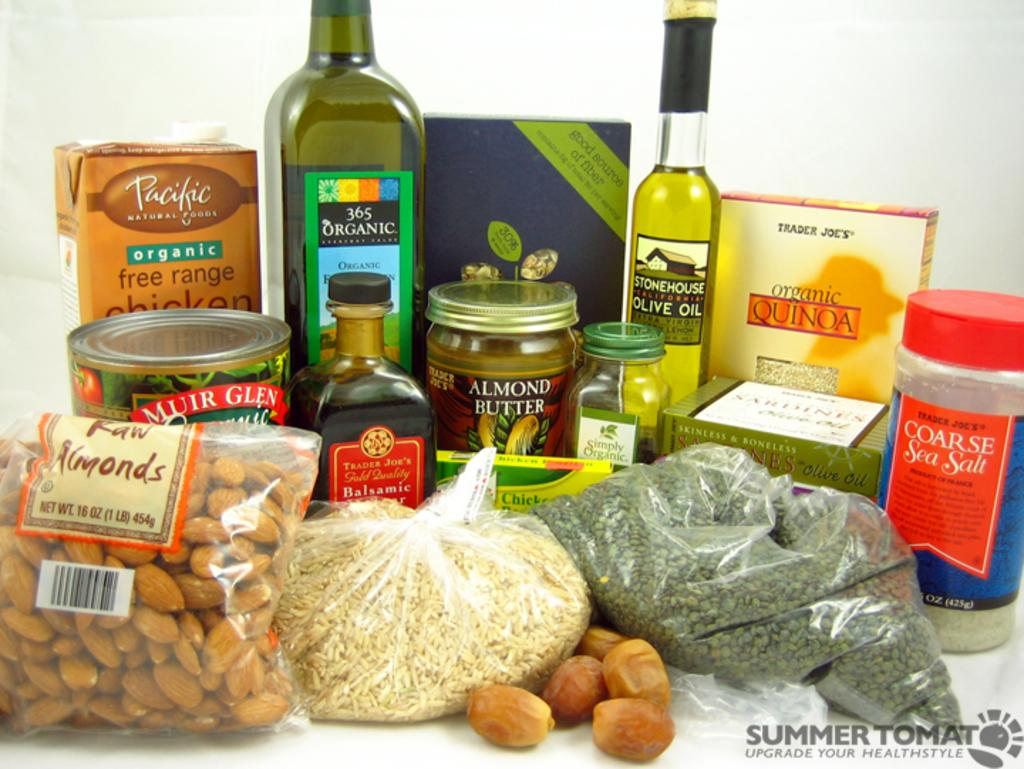Provide a one-sentence caption for the provided image. A 1lb bag of raw almonds sits next to a bag of rice. 